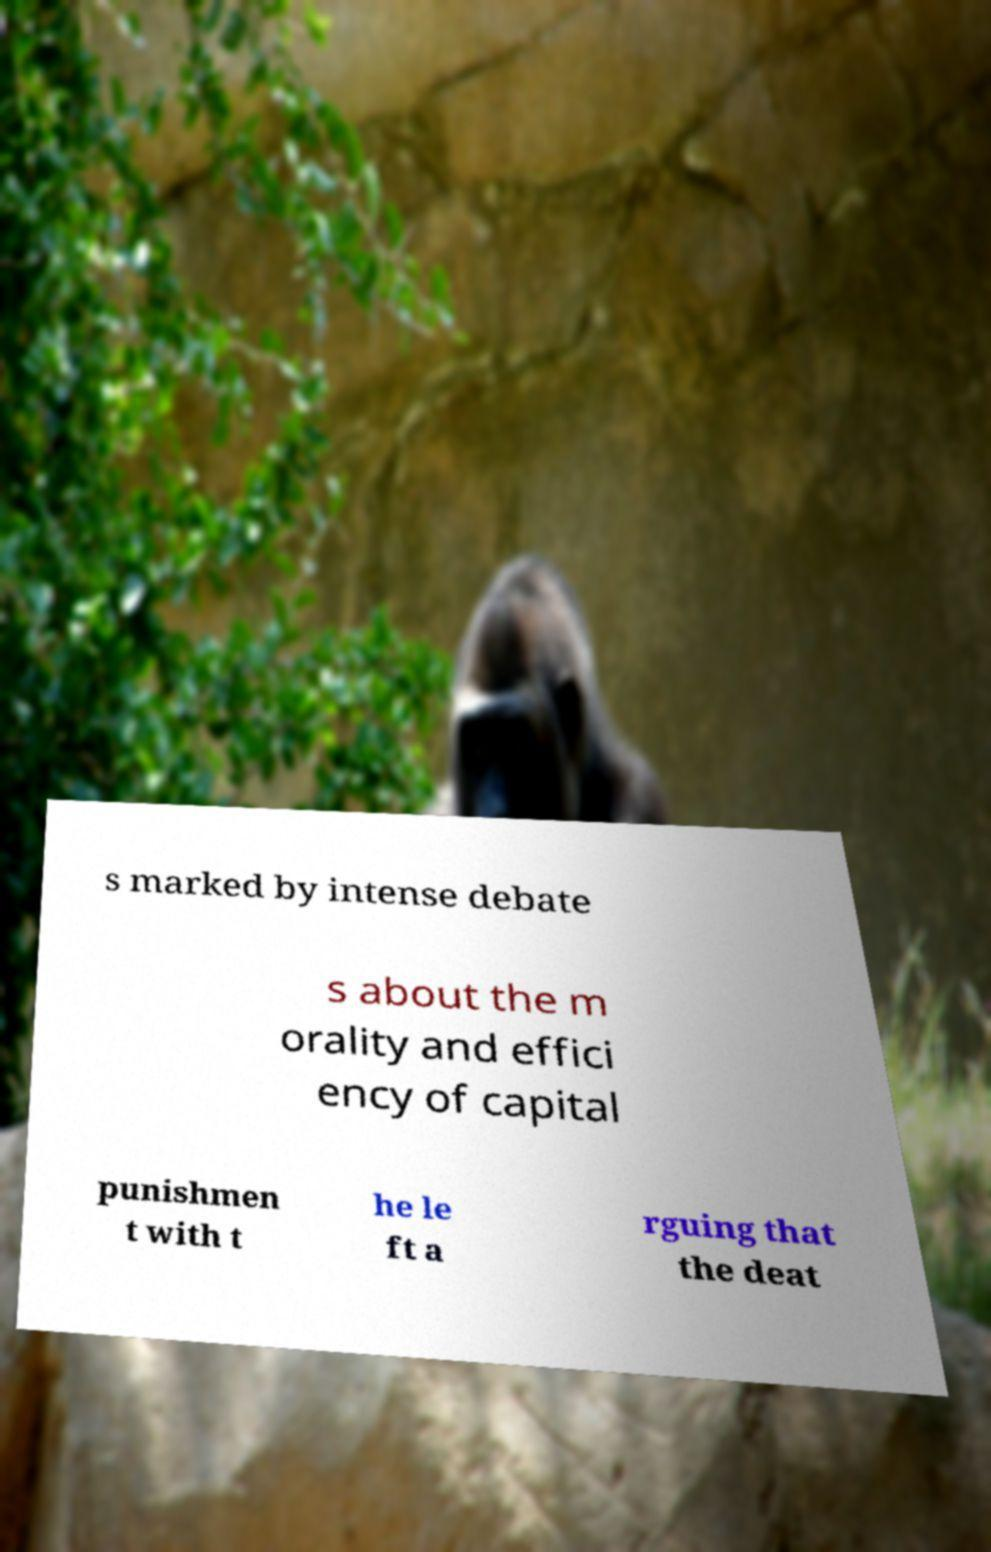There's text embedded in this image that I need extracted. Can you transcribe it verbatim? s marked by intense debate s about the m orality and effici ency of capital punishmen t with t he le ft a rguing that the deat 